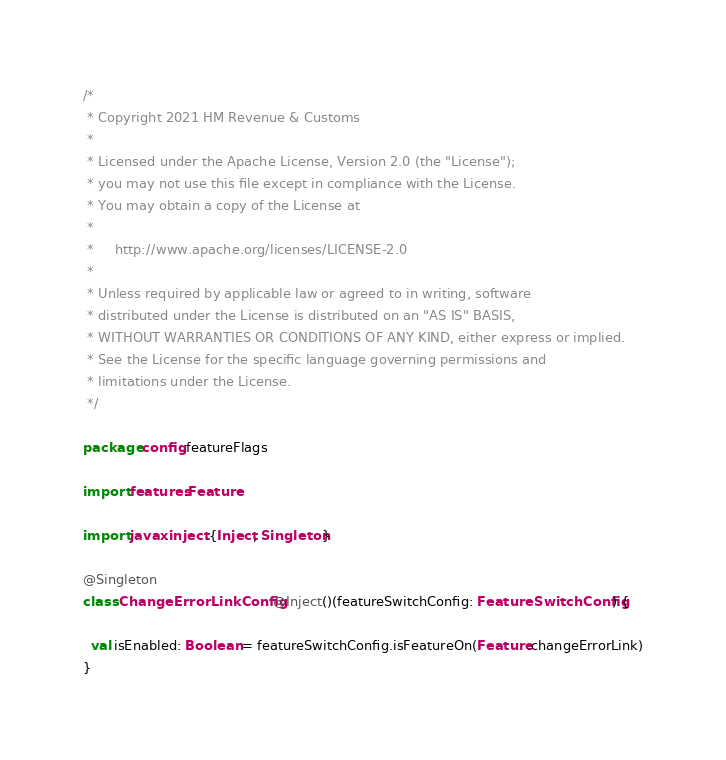<code> <loc_0><loc_0><loc_500><loc_500><_Scala_>/*
 * Copyright 2021 HM Revenue & Customs
 *
 * Licensed under the Apache License, Version 2.0 (the "License");
 * you may not use this file except in compliance with the License.
 * You may obtain a copy of the License at
 *
 *     http://www.apache.org/licenses/LICENSE-2.0
 *
 * Unless required by applicable law or agreed to in writing, software
 * distributed under the License is distributed on an "AS IS" BASIS,
 * WITHOUT WARRANTIES OR CONDITIONS OF ANY KIND, either express or implied.
 * See the License for the specific language governing permissions and
 * limitations under the License.
 */

package config.featureFlags

import features.Feature

import javax.inject.{Inject, Singleton}

@Singleton
class ChangeErrorLinkConfig @Inject()(featureSwitchConfig: FeatureSwitchConfig) {

  val isEnabled: Boolean = featureSwitchConfig.isFeatureOn(Feature.changeErrorLink)
}
</code> 